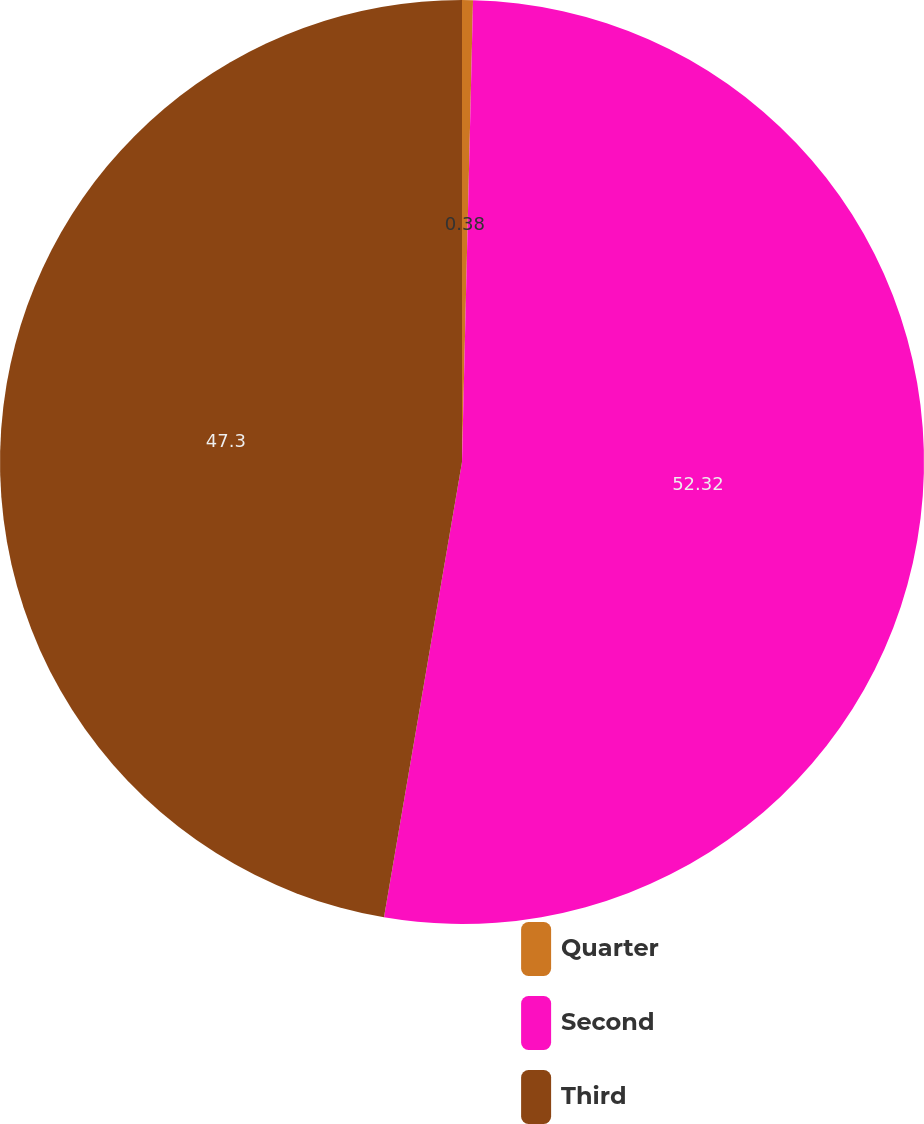<chart> <loc_0><loc_0><loc_500><loc_500><pie_chart><fcel>Quarter<fcel>Second<fcel>Third<nl><fcel>0.38%<fcel>52.32%<fcel>47.3%<nl></chart> 